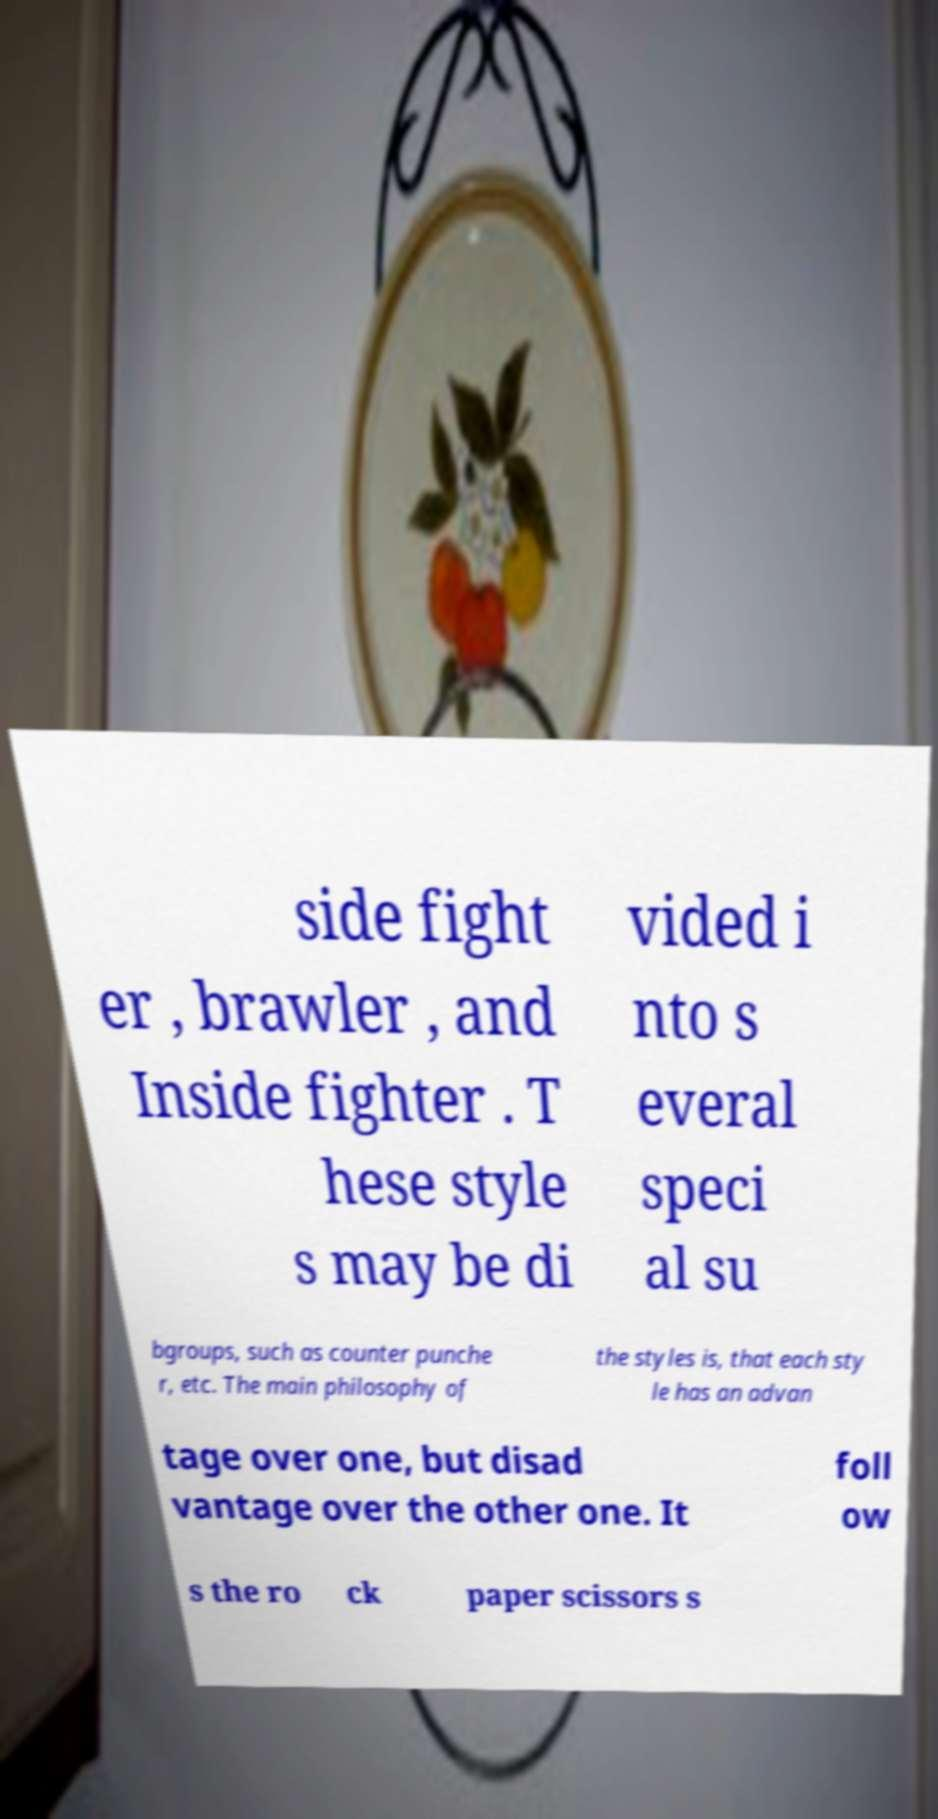Can you read and provide the text displayed in the image?This photo seems to have some interesting text. Can you extract and type it out for me? side fight er , brawler , and Inside fighter . T hese style s may be di vided i nto s everal speci al su bgroups, such as counter punche r, etc. The main philosophy of the styles is, that each sty le has an advan tage over one, but disad vantage over the other one. It foll ow s the ro ck paper scissors s 